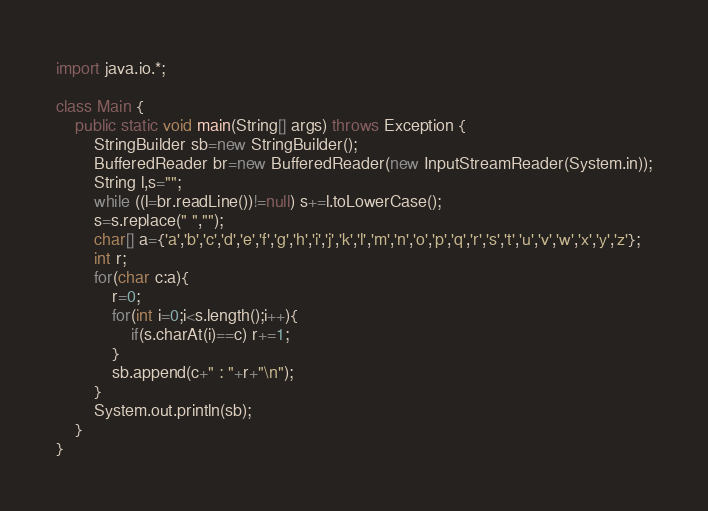Convert code to text. <code><loc_0><loc_0><loc_500><loc_500><_Java_>import java.io.*;

class Main {
	public static void main(String[] args) throws Exception {
		StringBuilder sb=new StringBuilder();
		BufferedReader br=new BufferedReader(new InputStreamReader(System.in));
		String l,s="";
		while ((l=br.readLine())!=null) s+=l.toLowerCase();
		s=s.replace(" ","");
		char[] a={'a','b','c','d','e','f','g','h','i','j','k','l','m','n','o','p','q','r','s','t','u','v','w','x','y','z'};
		int r;
        for(char c:a){
        	r=0;
        	for(int i=0;i<s.length();i++){
            	if(s.charAt(i)==c) r+=1; 
        	}
        	sb.append(c+" : "+r+"\n");
        }
        System.out.println(sb);
	}
}</code> 